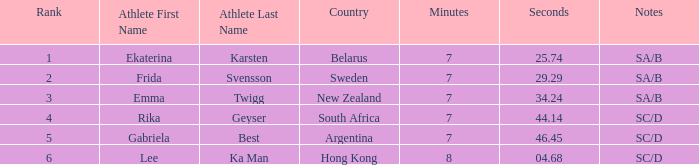What is the time of frida svensson's race that had sa/b under the notes? 7:29.29. 